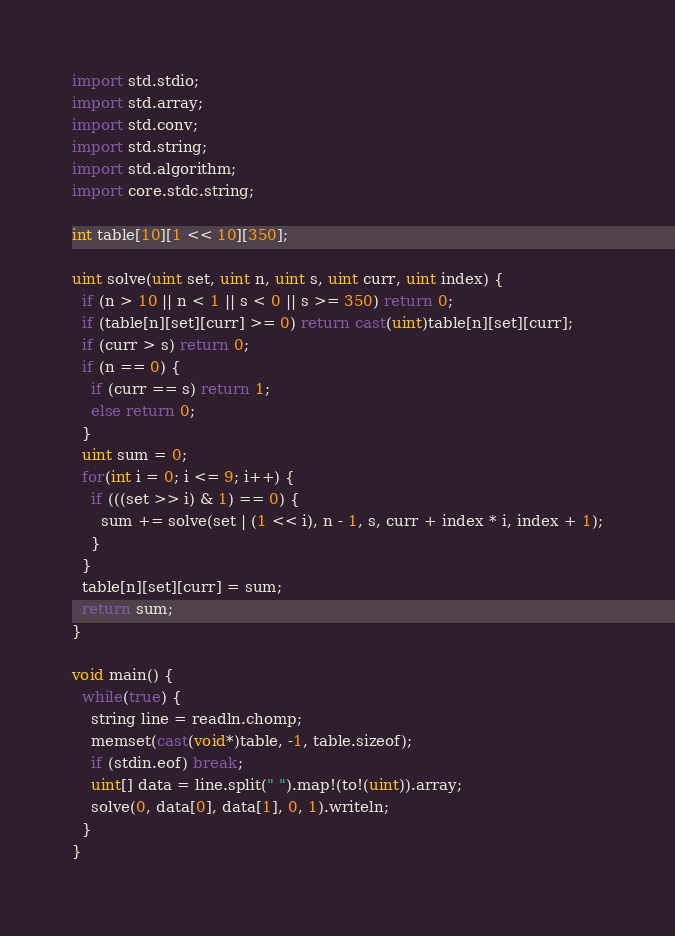<code> <loc_0><loc_0><loc_500><loc_500><_D_>
import std.stdio;
import std.array;
import std.conv;
import std.string;
import std.algorithm;
import core.stdc.string;

int table[10][1 << 10][350];

uint solve(uint set, uint n, uint s, uint curr, uint index) {
  if (n > 10 || n < 1 || s < 0 || s >= 350) return 0;
  if (table[n][set][curr] >= 0) return cast(uint)table[n][set][curr];
  if (curr > s) return 0;
  if (n == 0) {
    if (curr == s) return 1;
    else return 0;
  }
  uint sum = 0;
  for(int i = 0; i <= 9; i++) {
    if (((set >> i) & 1) == 0) {
      sum += solve(set | (1 << i), n - 1, s, curr + index * i, index + 1);
    }
  }
  table[n][set][curr] = sum;
  return sum;
}

void main() {
  while(true) {
    string line = readln.chomp;
    memset(cast(void*)table, -1, table.sizeof);
    if (stdin.eof) break;
    uint[] data = line.split(" ").map!(to!(uint)).array;
    solve(0, data[0], data[1], 0, 1).writeln;
  }
}</code> 